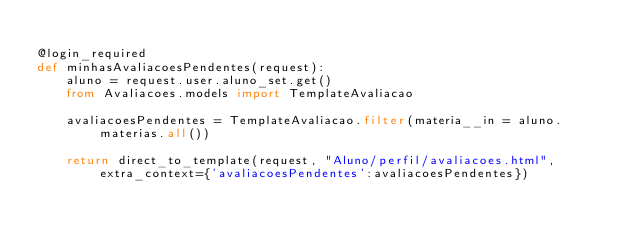Convert code to text. <code><loc_0><loc_0><loc_500><loc_500><_Python_>    
@login_required     
def minhasAvaliacoesPendentes(request):
    aluno = request.user.aluno_set.get()
    from Avaliacoes.models import TemplateAvaliacao
    
    avaliacoesPendentes = TemplateAvaliacao.filter(materia__in = aluno.materias.all())
    
    return direct_to_template(request, "Aluno/perfil/avaliacoes.html", extra_context={'avaliacoesPendentes':avaliacoesPendentes})
</code> 